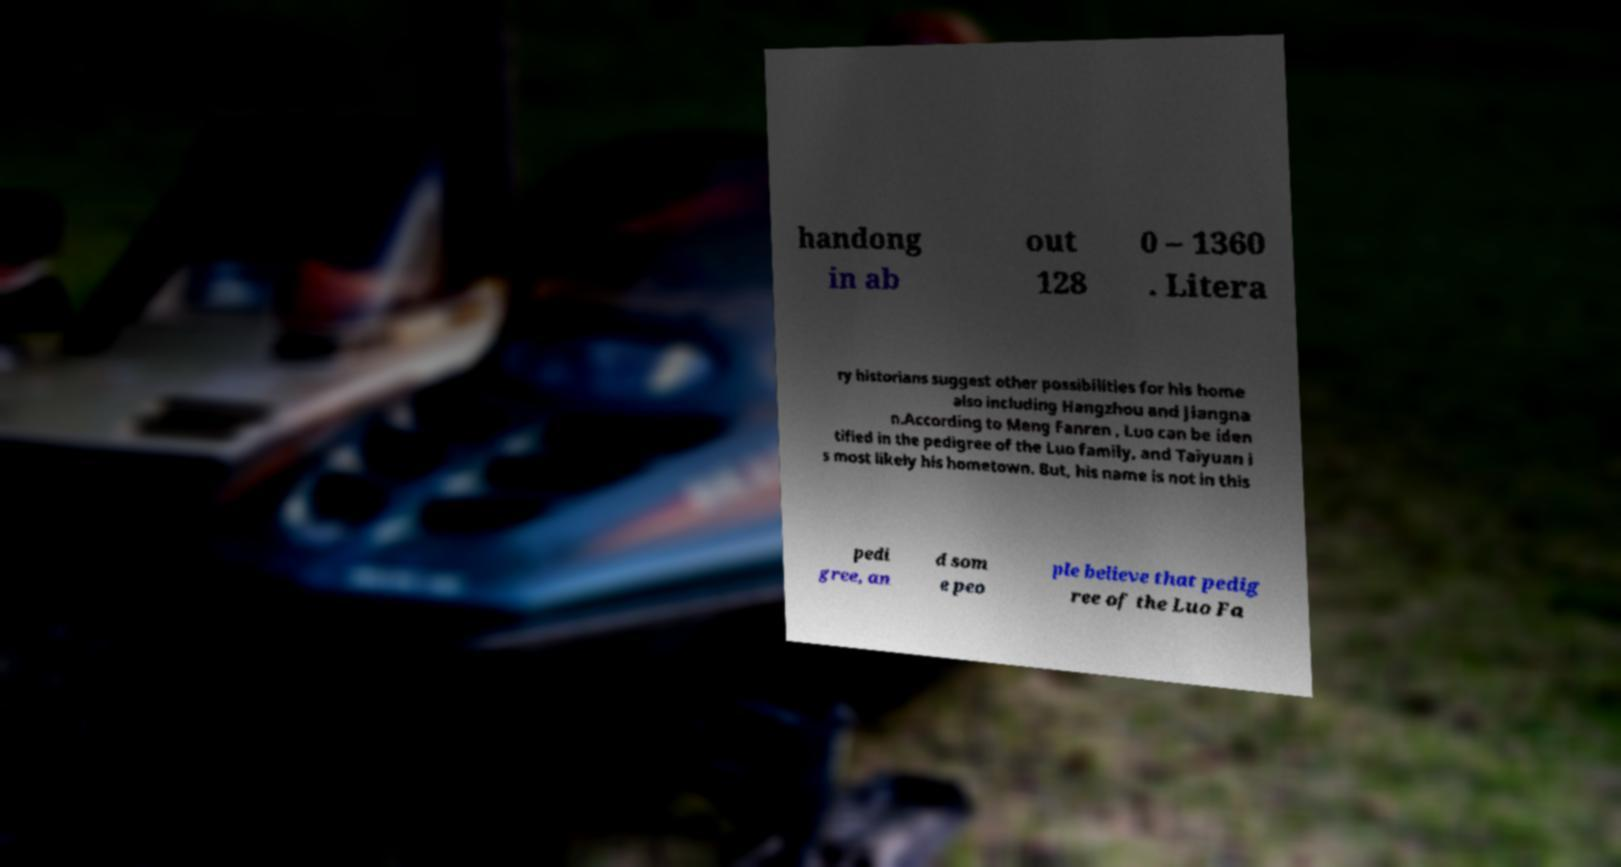Please identify and transcribe the text found in this image. handong in ab out 128 0 – 1360 . Litera ry historians suggest other possibilities for his home also including Hangzhou and Jiangna n.According to Meng Fanren , Luo can be iden tified in the pedigree of the Luo family, and Taiyuan i s most likely his hometown. But, his name is not in this pedi gree, an d som e peo ple believe that pedig ree of the Luo Fa 